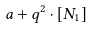<formula> <loc_0><loc_0><loc_500><loc_500>a + q ^ { 2 } \cdot [ N _ { 1 } ]</formula> 